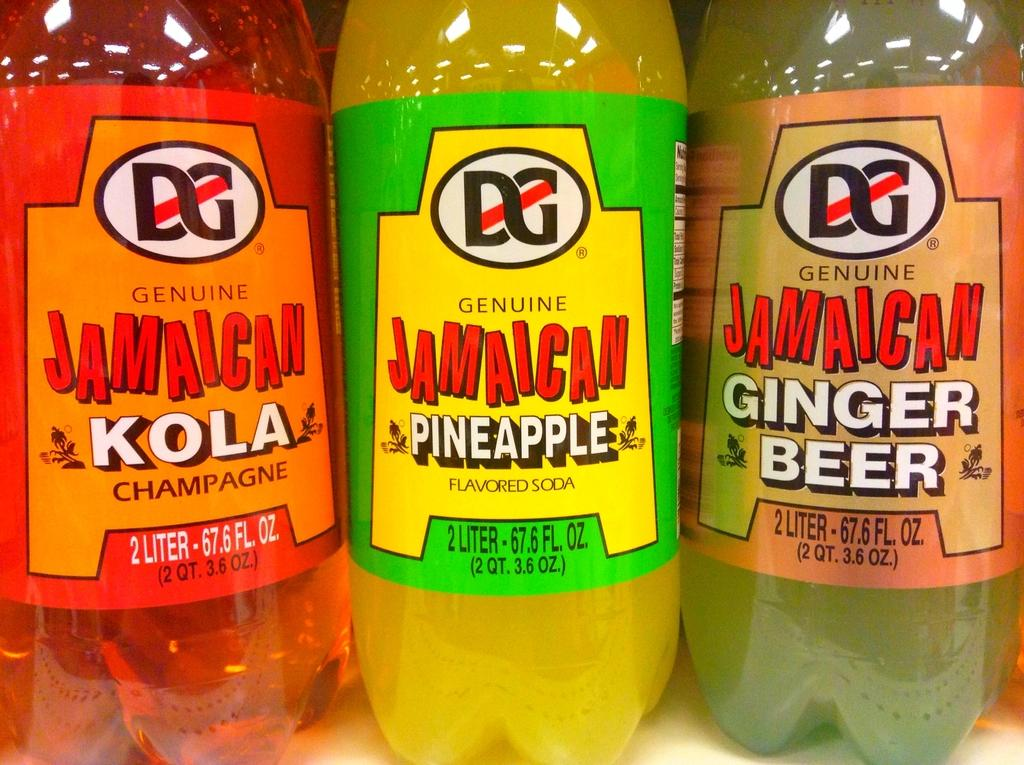Provide a one-sentence caption for the provided image. The genuine Jamaican brand drinks displayed in the quantity of 2 liter. 